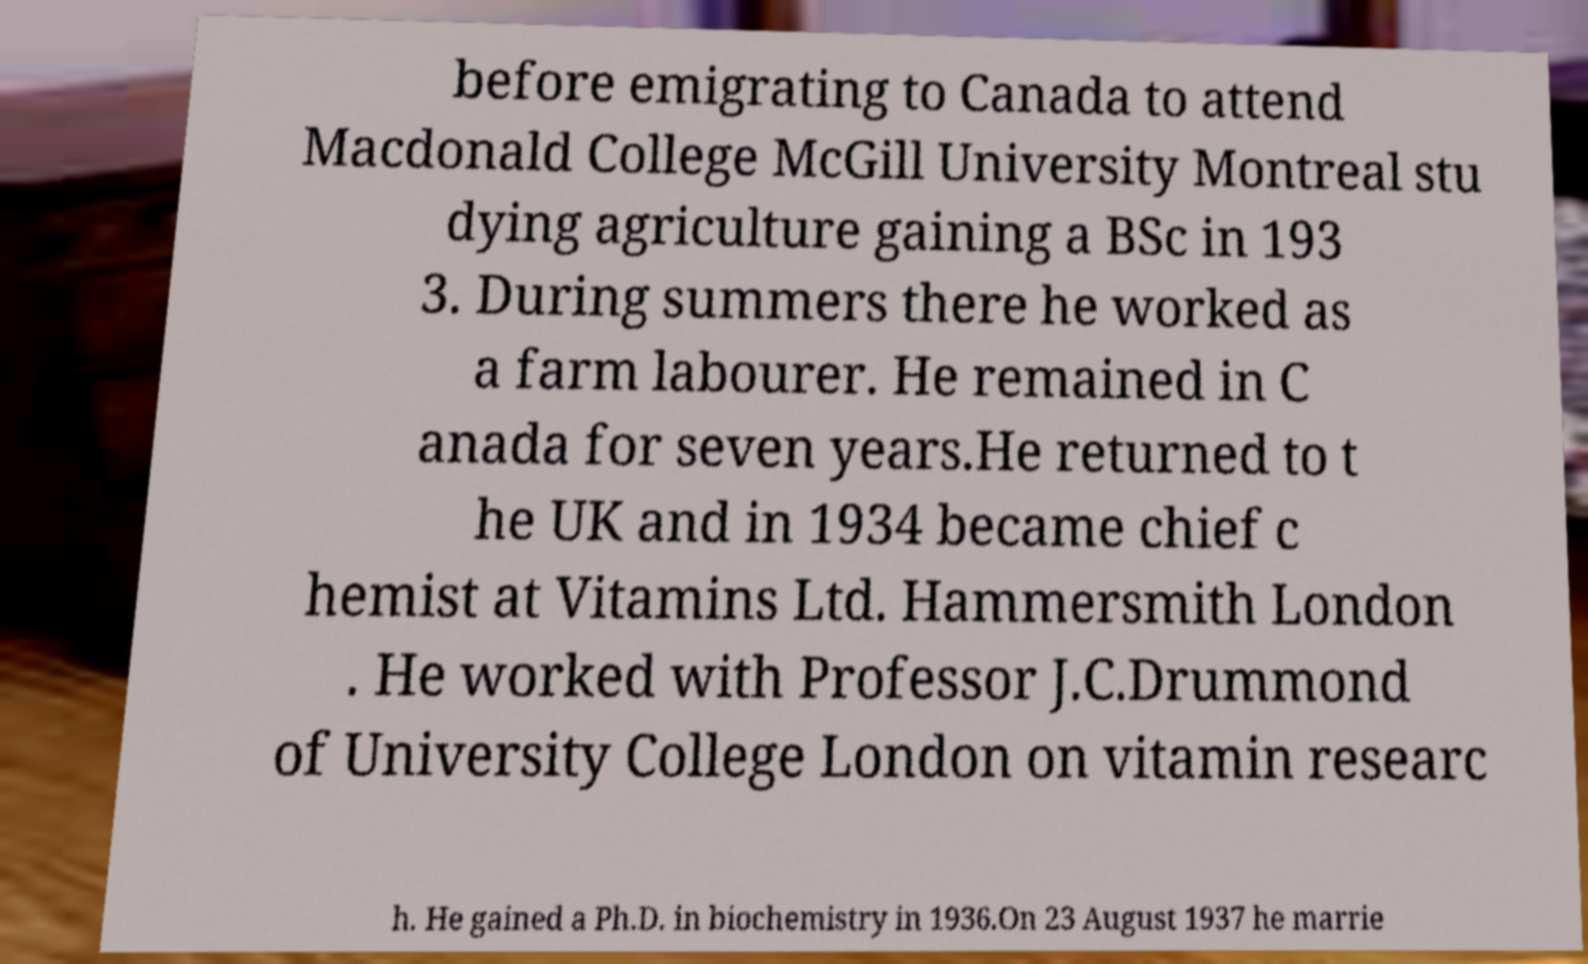Could you assist in decoding the text presented in this image and type it out clearly? before emigrating to Canada to attend Macdonald College McGill University Montreal stu dying agriculture gaining a BSc in 193 3. During summers there he worked as a farm labourer. He remained in C anada for seven years.He returned to t he UK and in 1934 became chief c hemist at Vitamins Ltd. Hammersmith London . He worked with Professor J.C.Drummond of University College London on vitamin researc h. He gained a Ph.D. in biochemistry in 1936.On 23 August 1937 he marrie 